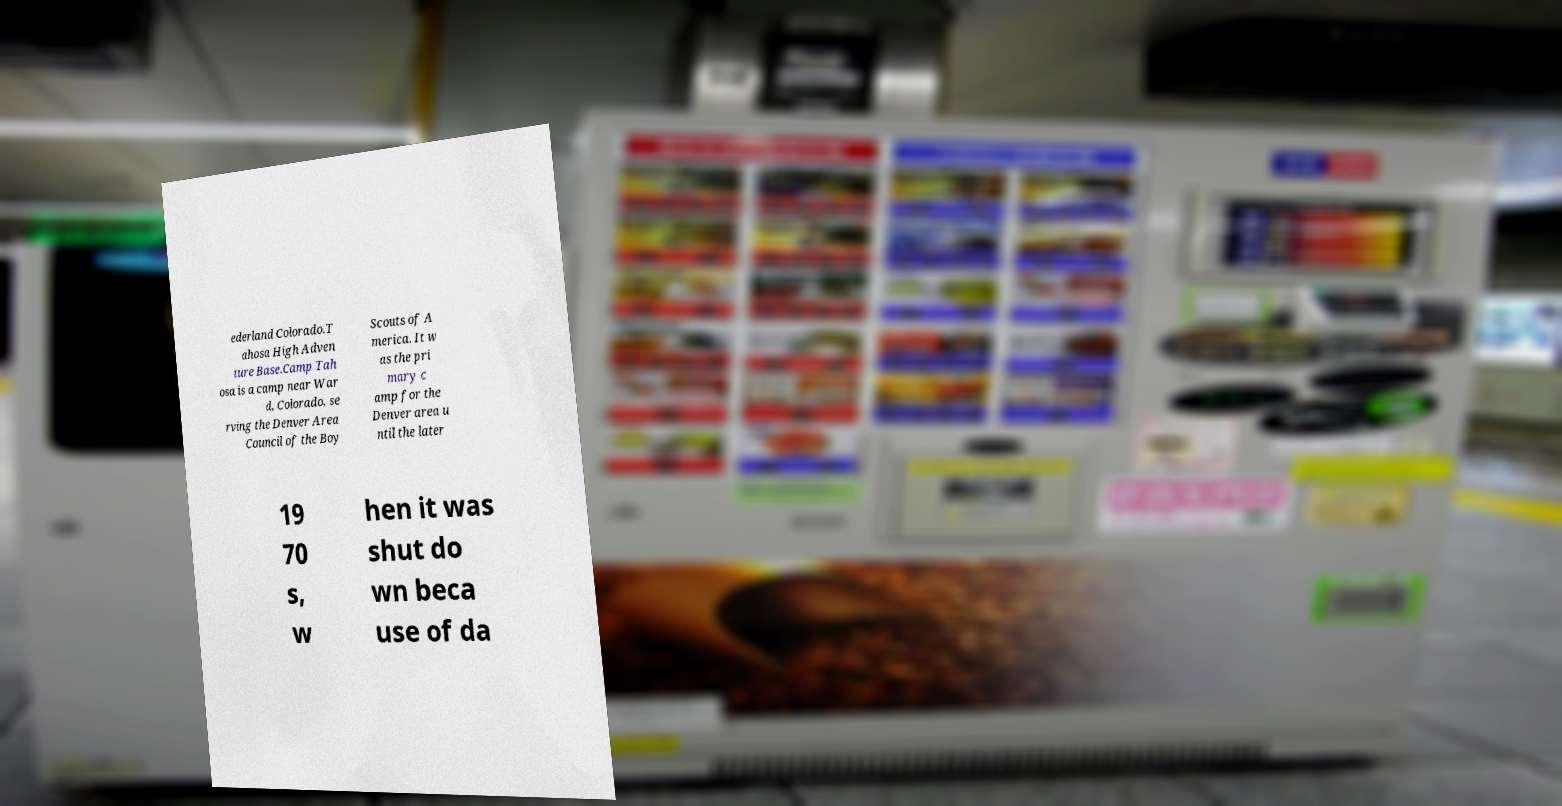Please read and relay the text visible in this image. What does it say? ederland Colorado.T ahosa High Adven ture Base.Camp Tah osa is a camp near War d, Colorado, se rving the Denver Area Council of the Boy Scouts of A merica. It w as the pri mary c amp for the Denver area u ntil the later 19 70 s, w hen it was shut do wn beca use of da 